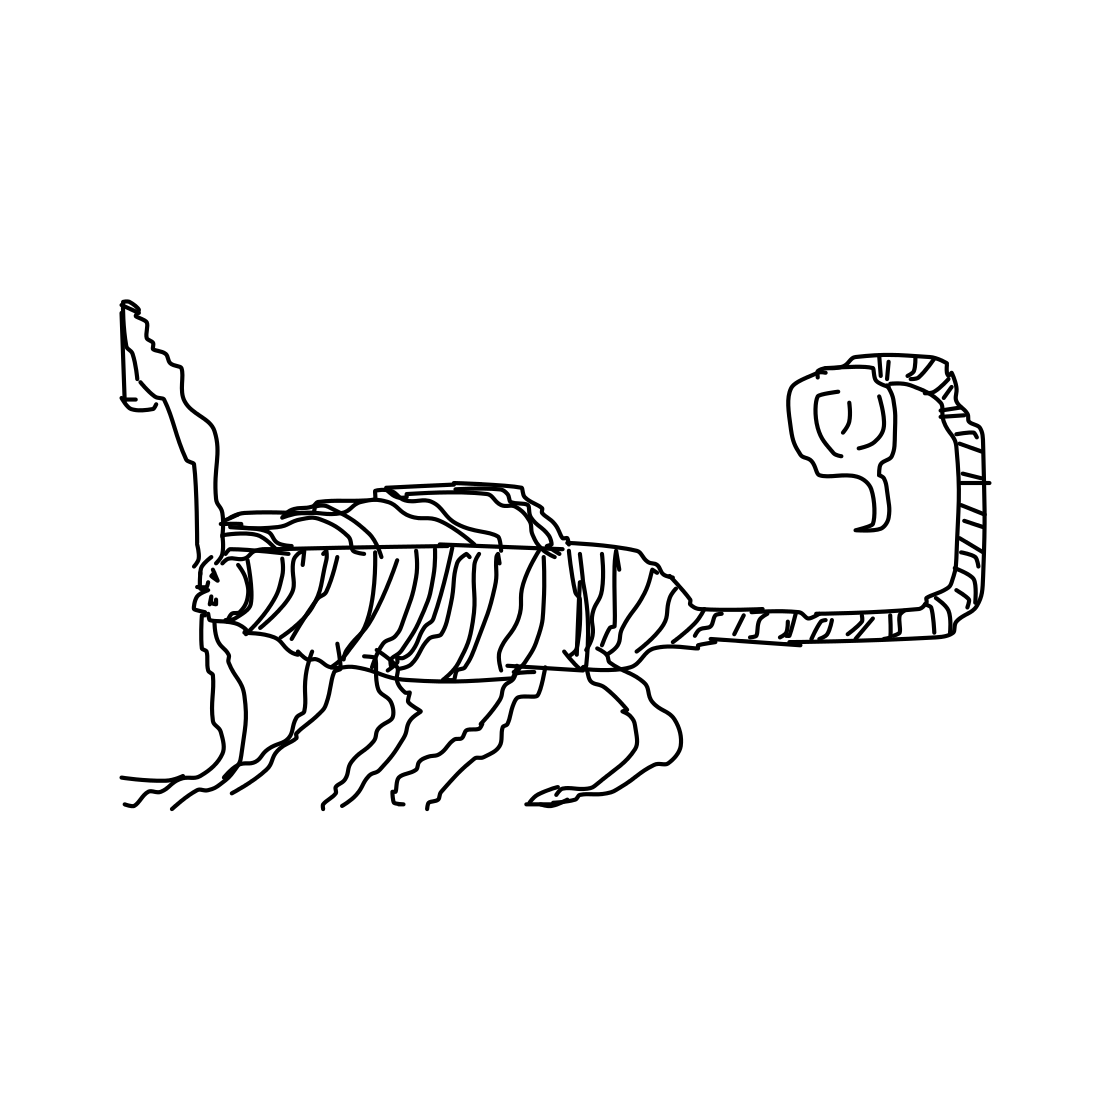Is there a sketchy squirrel in the picture? I see an abstract sketch that appears to be a blend of various animal features rather than a squirrel. The drawing resembles a mix of a feline and a horse, with stripe-like patterns that add to its imaginative charm. 